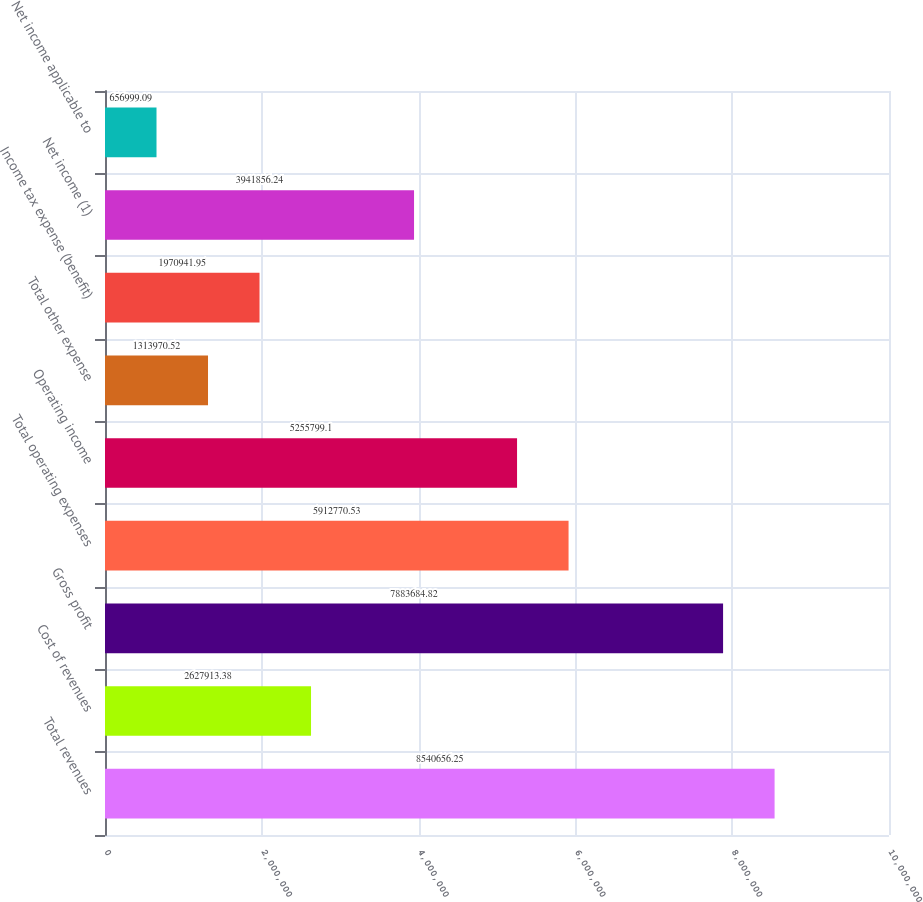Convert chart. <chart><loc_0><loc_0><loc_500><loc_500><bar_chart><fcel>Total revenues<fcel>Cost of revenues<fcel>Gross profit<fcel>Total operating expenses<fcel>Operating income<fcel>Total other expense<fcel>Income tax expense (benefit)<fcel>Net income (1)<fcel>Net income applicable to<nl><fcel>8.54066e+06<fcel>2.62791e+06<fcel>7.88368e+06<fcel>5.91277e+06<fcel>5.2558e+06<fcel>1.31397e+06<fcel>1.97094e+06<fcel>3.94186e+06<fcel>656999<nl></chart> 